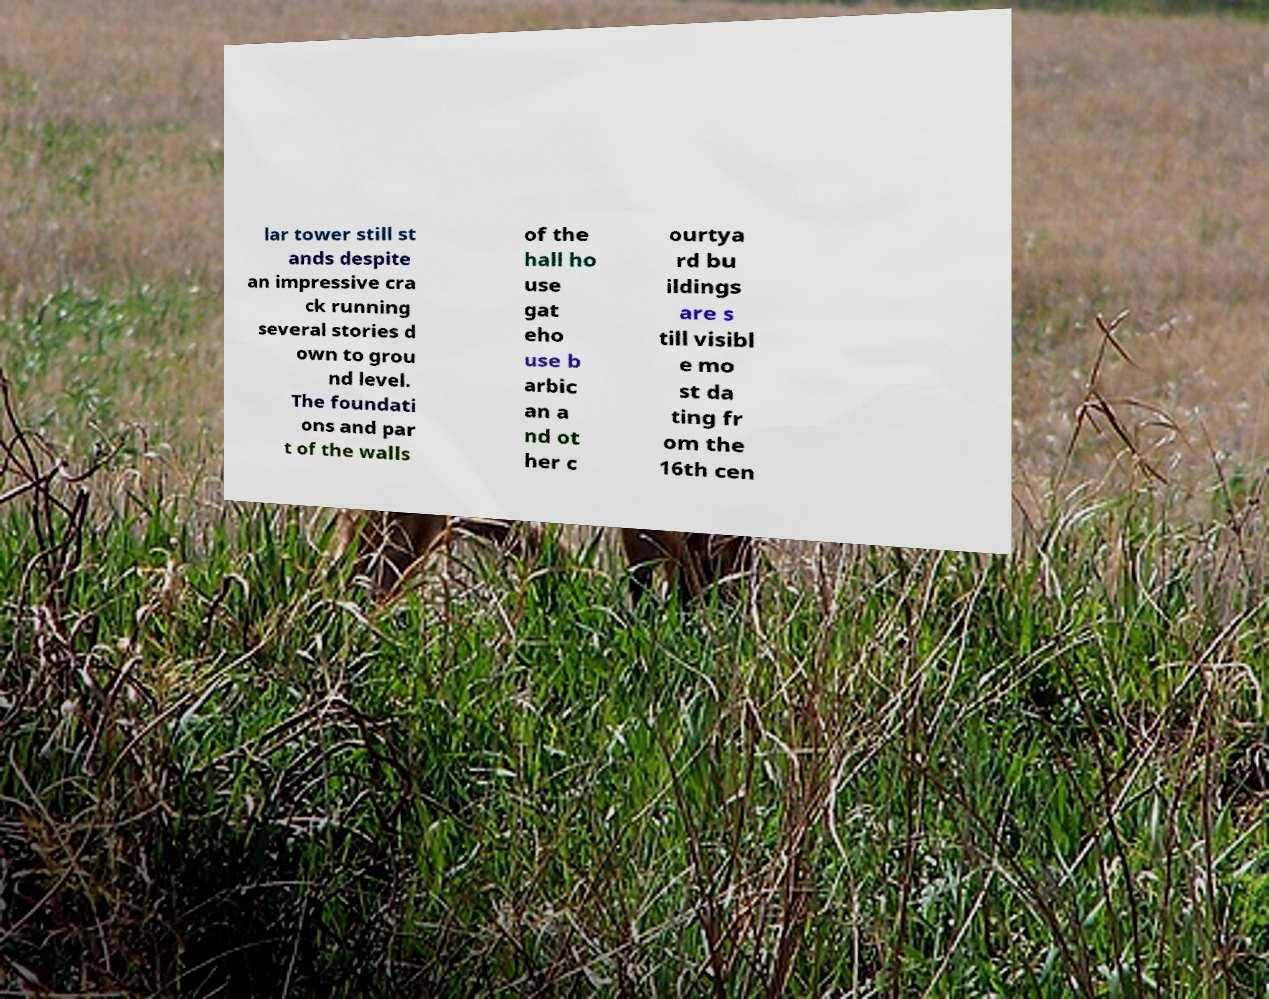For documentation purposes, I need the text within this image transcribed. Could you provide that? lar tower still st ands despite an impressive cra ck running several stories d own to grou nd level. The foundati ons and par t of the walls of the hall ho use gat eho use b arbic an a nd ot her c ourtya rd bu ildings are s till visibl e mo st da ting fr om the 16th cen 